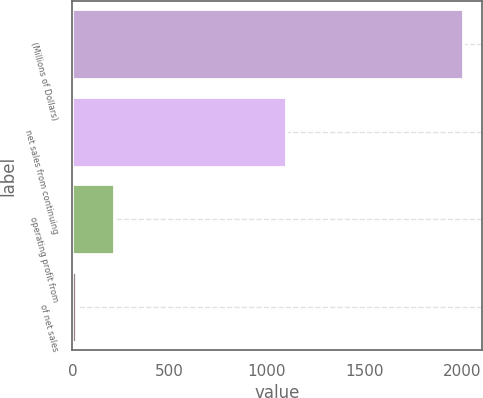Convert chart to OTSL. <chart><loc_0><loc_0><loc_500><loc_500><bar_chart><fcel>(Millions of Dollars)<fcel>net sales from continuing<fcel>operating profit from<fcel>of net sales<nl><fcel>2005<fcel>1098<fcel>215.71<fcel>16.9<nl></chart> 